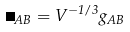Convert formula to latex. <formula><loc_0><loc_0><loc_500><loc_500>\Omega _ { A B } = V ^ { - 1 / 3 } g _ { A B }</formula> 